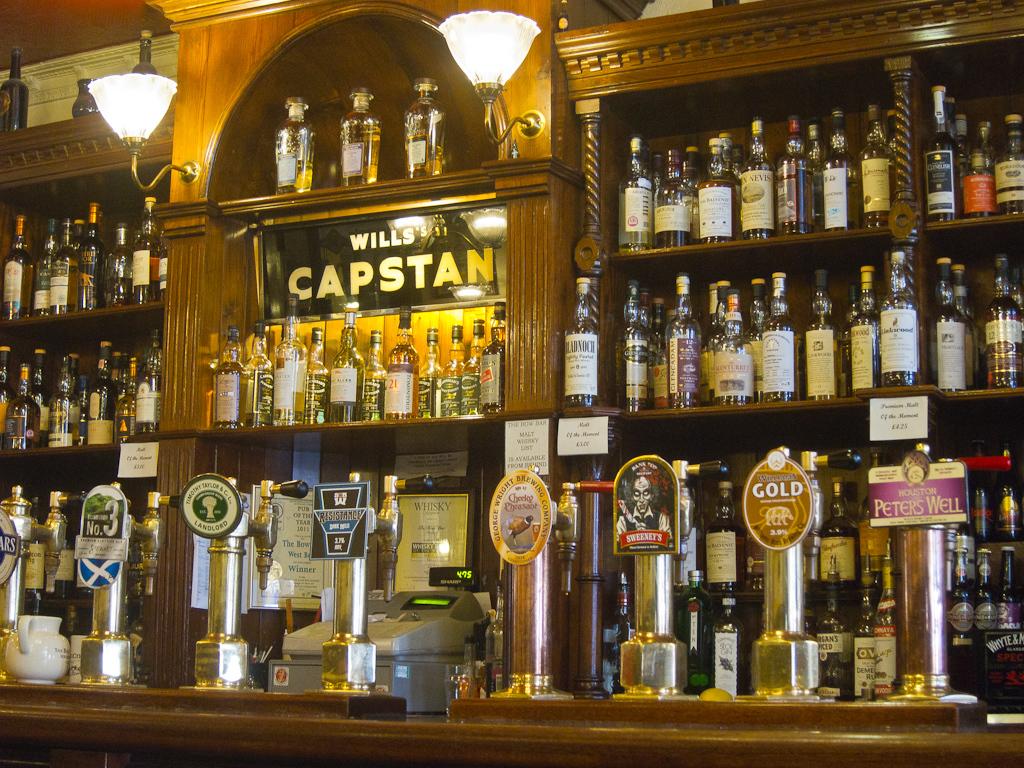What brand is on the bigger sign?
Keep it short and to the point. Wills capstan. What beer is said on the second to right?
Ensure brevity in your answer.  Gold. 